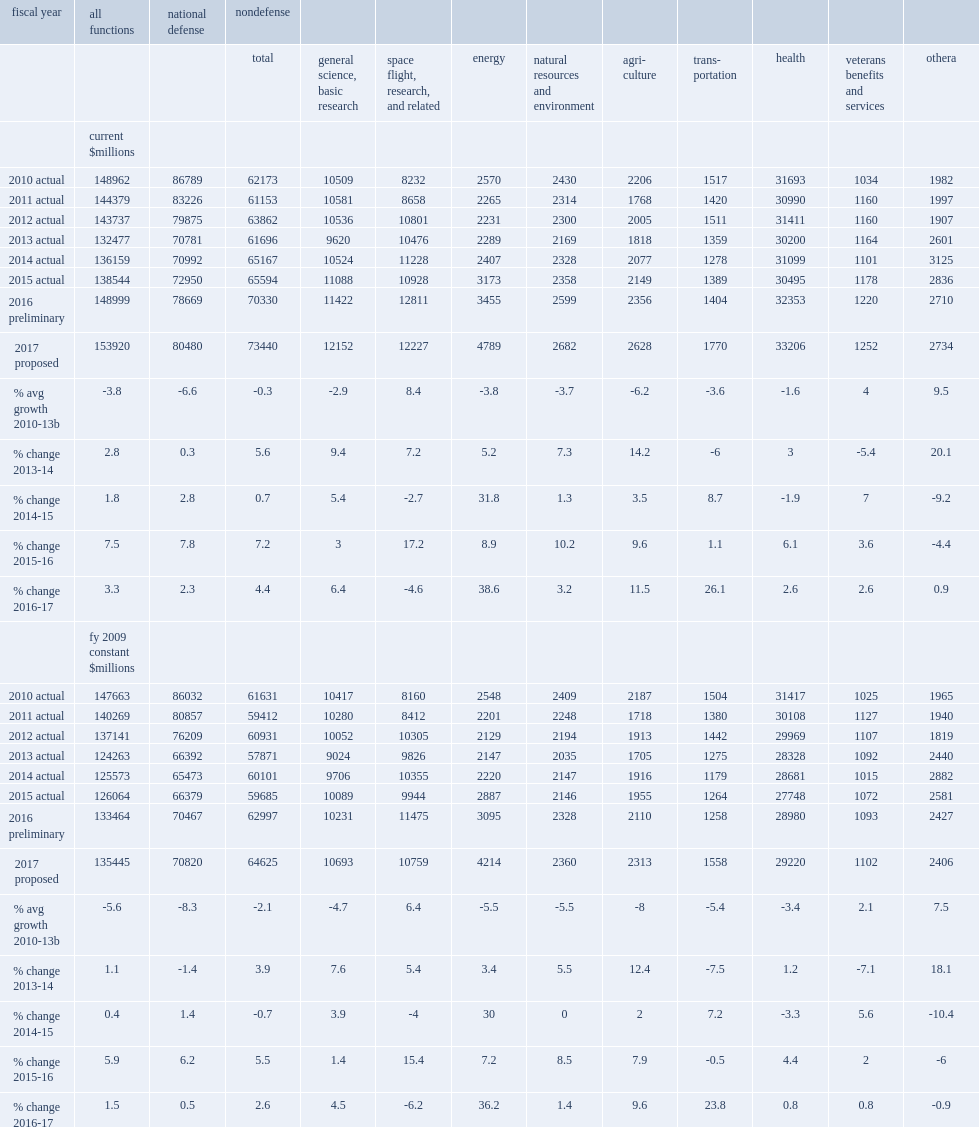How many million dollars did federal budget authority for research and development and r&d plant together total in fy 2016? 148999.0. Federal budget authority for research and development and r&d plant together totaled an estimated $149.0 million in fy 2016, what was an increase of million dollars over the fy 2015 level? 10455. Federal budget authority for research and development and r&d plant together totaled an estimated $149.0 billion in fy 2016, what was an increase of percent over the fy 2015 level? 7.5. How many million dollars of increase in fy 2015? 2385. How many percent of increase in fy 2015? 1.8. How many million dollars of increase in fy 2014? 3682. How many percent of increase in fy 2014? 2.8. How many million dollars did the president's proposed budget for the federal government in fy 2017 calls for in funding for r&d and r&d plant? 153920.0. The president's proposed budget for the federal government in fy 2017 calls for $153.9 million in funding for r&d and r&d plant, hwo many million dollars of increase over the previous year? 4921. The president's proposed budget for the federal government in fy 2017 calls for $153.9 billion in funding for r&d and r&d plant, how many percent of increase over the previous year? 3.3. 